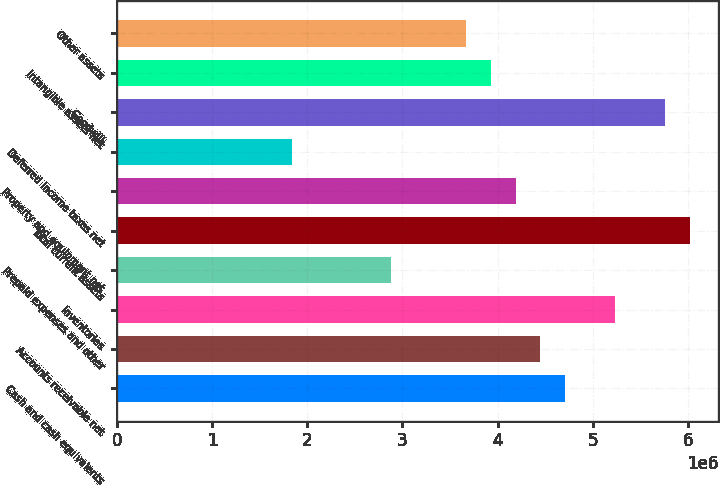Convert chart. <chart><loc_0><loc_0><loc_500><loc_500><bar_chart><fcel>Cash and cash equivalents<fcel>Accounts receivable net<fcel>Inventories<fcel>Prepaid expenses and other<fcel>Total current assets<fcel>Property and equipment net<fcel>Deferred income taxes net<fcel>Goodwill<fcel>Intangible assets net<fcel>Other assets<nl><fcel>4.71361e+06<fcel>4.45187e+06<fcel>5.23708e+06<fcel>2.88144e+06<fcel>6.02229e+06<fcel>4.19013e+06<fcel>1.83449e+06<fcel>5.76056e+06<fcel>3.92839e+06<fcel>3.66666e+06<nl></chart> 